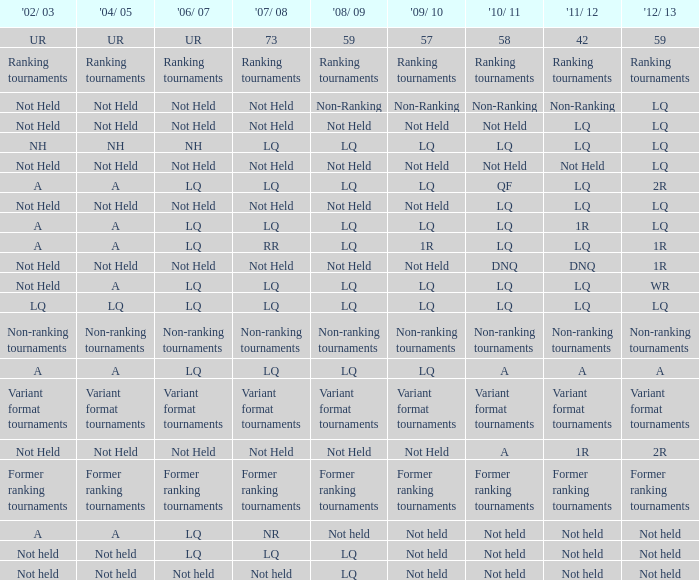Name the 2009/10 with 2011/12 of lq and 2008/09 of not held Not Held, Not Held. 